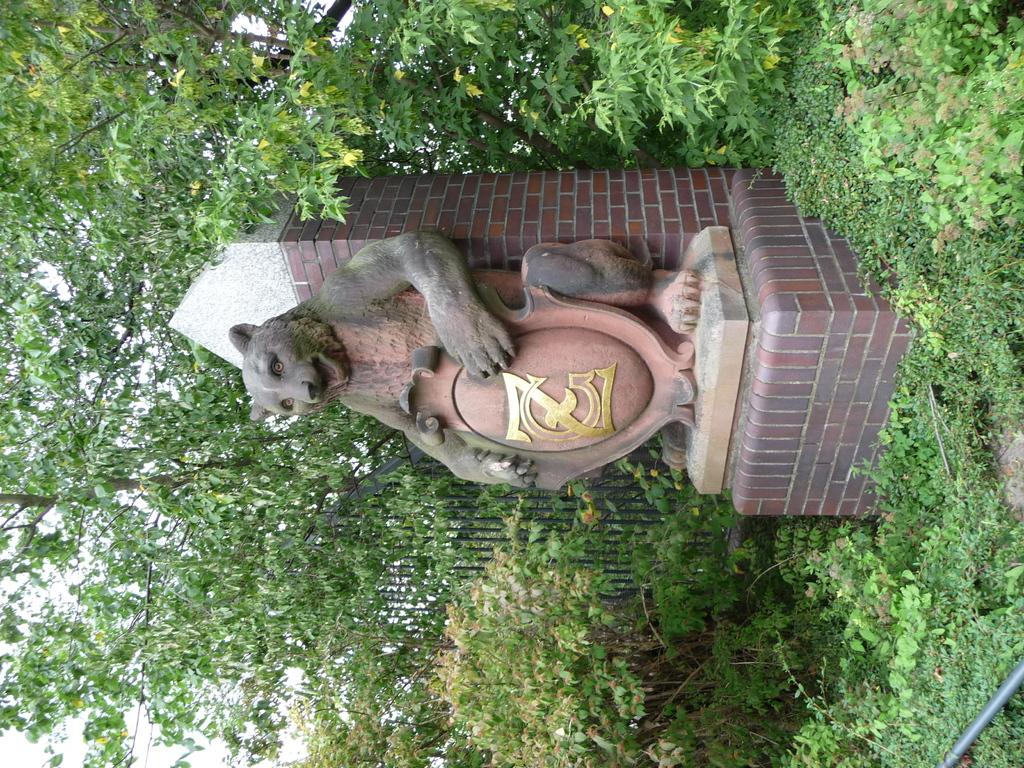What is the main subject in the center of the image? There is a depiction of an animal in the center of the image. What can be seen in the background of the image? There are trees in the background of the image. What type of vegetation is present at the bottom of the image? There are plants at the bottom of the image. What type of pest can be seen crawling on the base of the image? There is no base or pest present in the image; it features a depiction of an animal with trees in the background and plants at the bottom. 